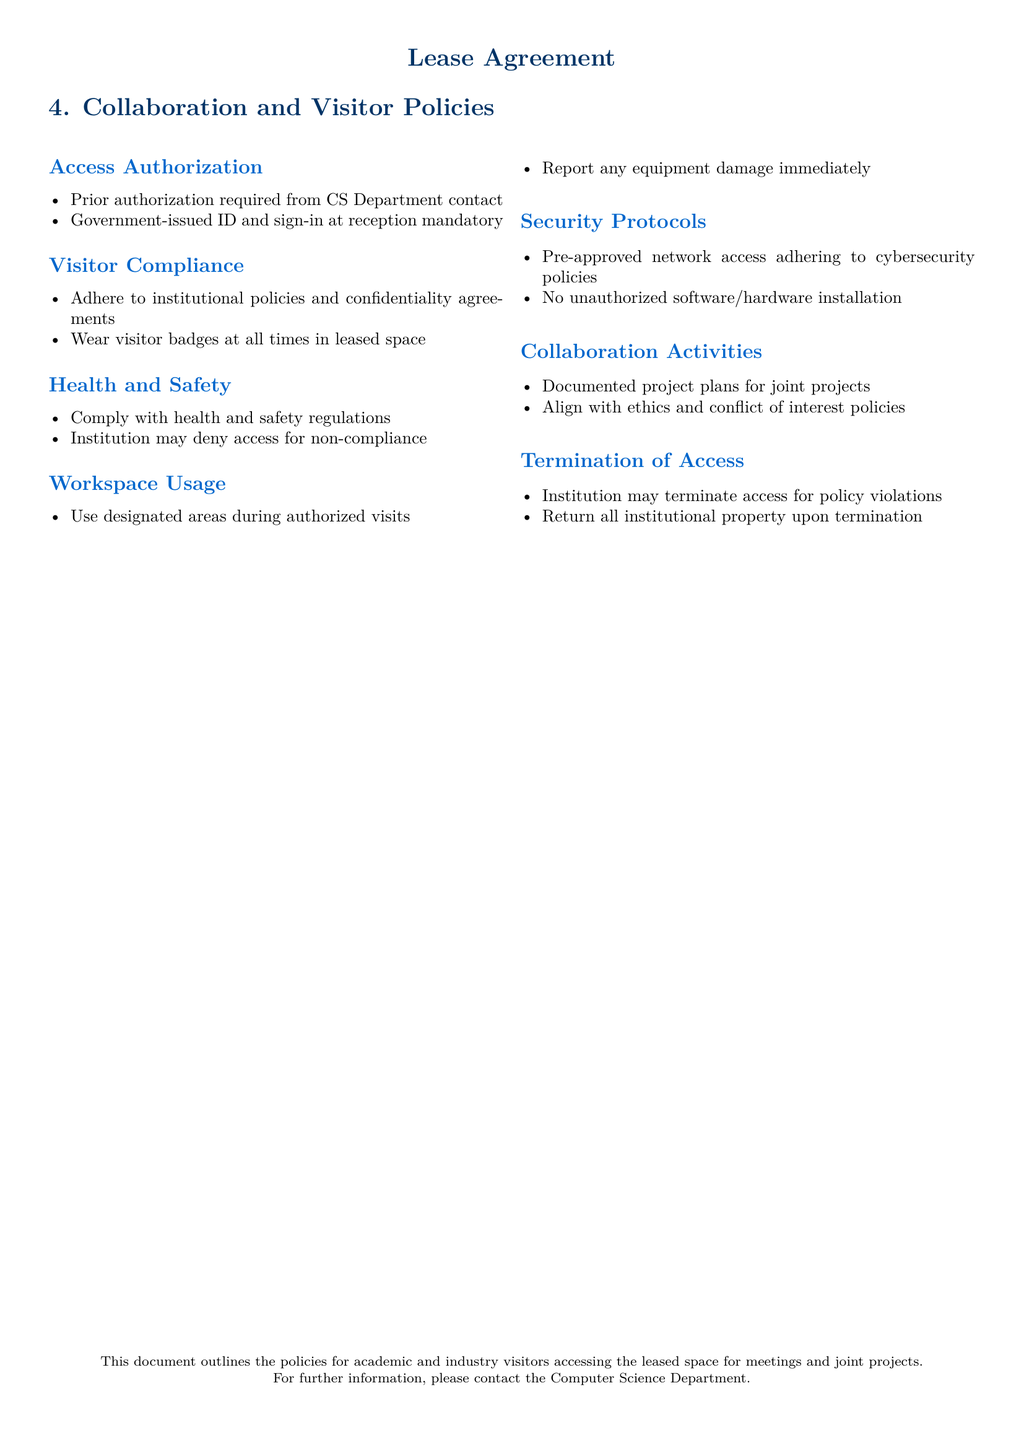What is required for access authorization? Access authorization requires prior authorization from the CS Department contact and a government-issued ID with sign-in at reception.
Answer: Prior authorization required from CS Department contact What must visitors wear at all times in the leased space? Visitors are required to wear visitor badges at all times while in the leased space.
Answer: Visitor badges What can happen if health and safety regulations are not complied with? Non-compliance with health and safety regulations may result in the institution denying access.
Answer: Deny access What must visitors do if they damage equipment during their visit? Visitors are required to report any equipment damage immediately.
Answer: Report damage immediately What type of access is needed for collaborative projects? Collaboration activities require documented project plans that align with ethics and conflict of interest policies.
Answer: Documented project plans What happens to access upon policy violations? The institution may terminate access for policy violations.
Answer: Terminate access What should be done with institutional property after termination of access? All institutional property must be returned upon termination of access.
Answer: Return all institutional property What is the policy regarding unauthorized software or hardware installation? Unauthorized software or hardware installation is not allowed in the leased space.
Answer: No unauthorized installation 